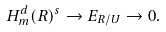<formula> <loc_0><loc_0><loc_500><loc_500>H ^ { d } _ { m } ( R ) ^ { s } \to E _ { R / U } \to 0 .</formula> 